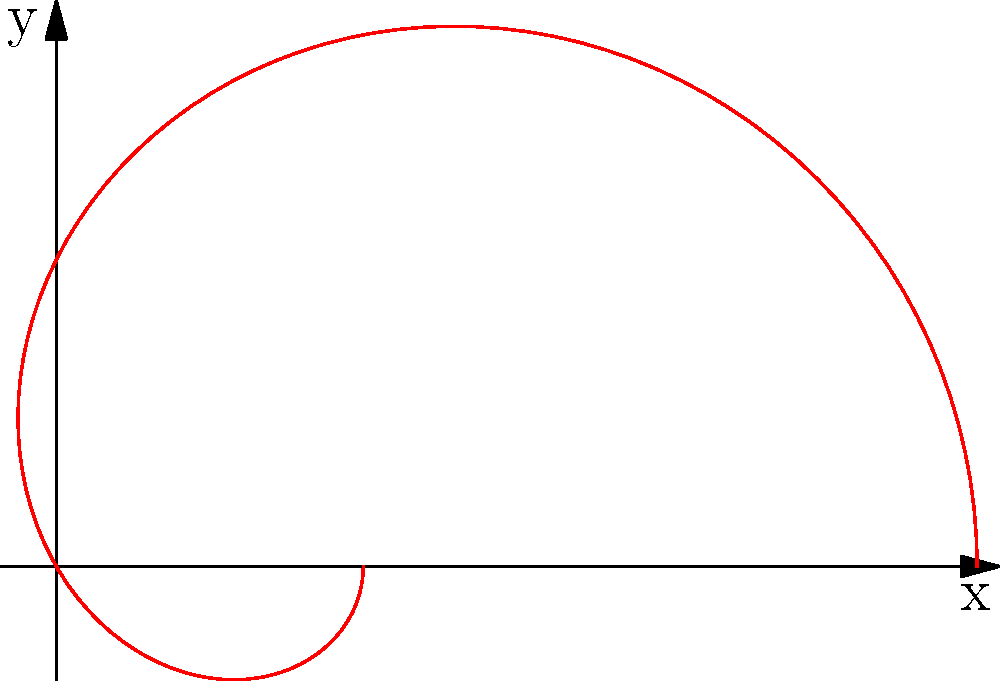An antenna has a directivity pattern given by the equation $D(\theta) = 1 + 2\cos(\theta)$, where $\theta$ is the angle from the antenna's axis. Calculate the antenna's maximum directivity and its gain in dB, assuming the antenna efficiency is 80%. To solve this problem, we'll follow these steps:

1) The maximum directivity occurs at $\theta = 0^\circ$ (along the antenna's axis):
   $D_{max} = D(0^\circ) = 1 + 2\cos(0^\circ) = 1 + 2 = 3$

2) To find the antenna gain, we need to consider the antenna efficiency:
   Gain = Efficiency * Directivity
   
   Given efficiency = 80% = 0.8
   
   Gain = $0.8 * 3 = 2.4$

3) To express the gain in dB:
   $\text{Gain (dB)} = 10 \log_{10}(\text{Gain})$
   $= 10 \log_{10}(2.4)$
   $\approx 3.80$ dB

Therefore, the antenna's maximum directivity is 3, and its gain is approximately 3.80 dB.
Answer: Maximum directivity: 3, Gain: 3.80 dB 